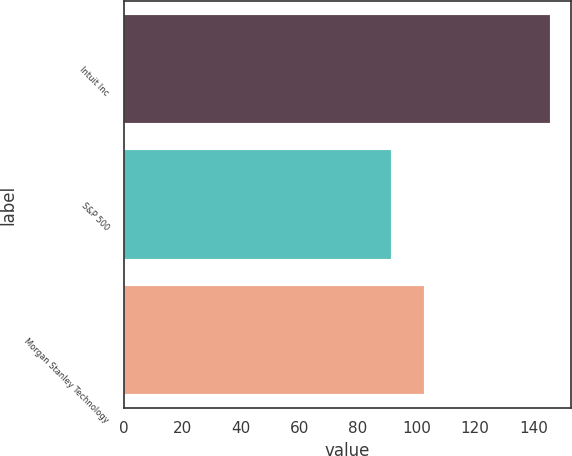Convert chart to OTSL. <chart><loc_0><loc_0><loc_500><loc_500><bar_chart><fcel>Intuit Inc<fcel>S&P 500<fcel>Morgan Stanley Technology<nl><fcel>145.44<fcel>91.11<fcel>102.64<nl></chart> 